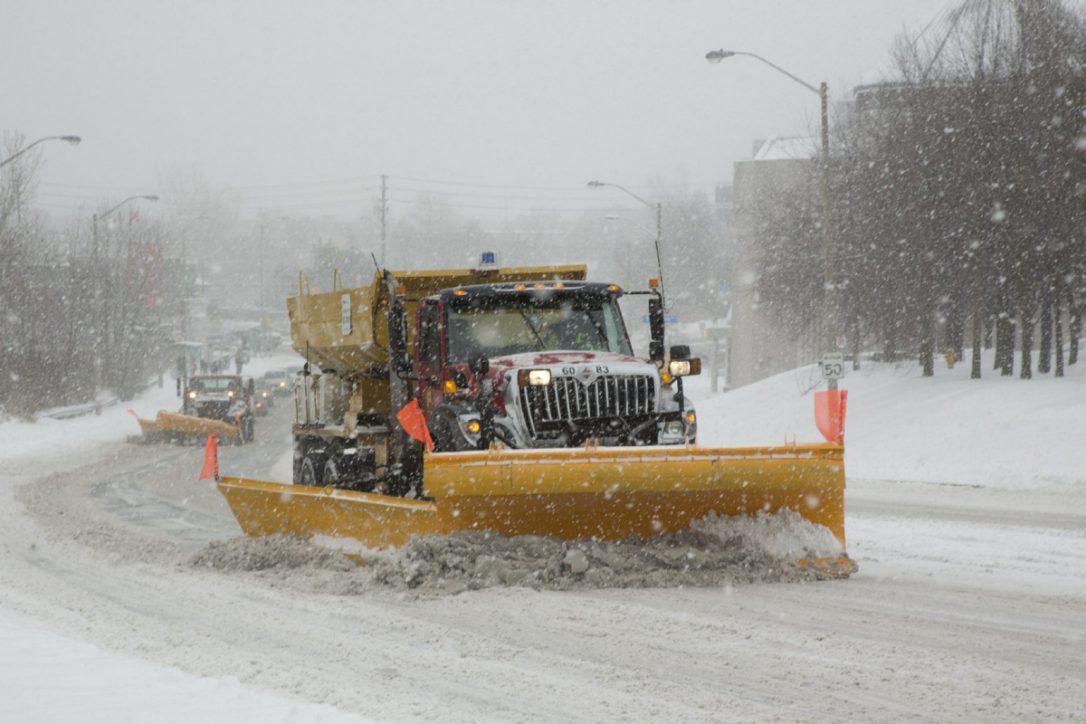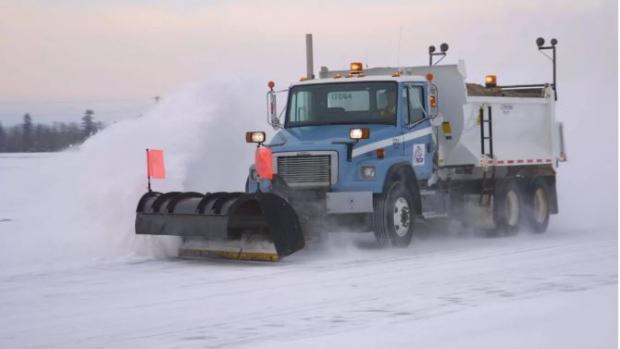The first image is the image on the left, the second image is the image on the right. Given the left and right images, does the statement "An image shows a truck with wheels instead of tank tracks heading rightward pushing snow, and the truck bed is bright yellow." hold true? Answer yes or no. Yes. The first image is the image on the left, the second image is the image on the right. Analyze the images presented: Is the assertion "The yellow truck is pushing the snow in the image on the left." valid? Answer yes or no. Yes. 